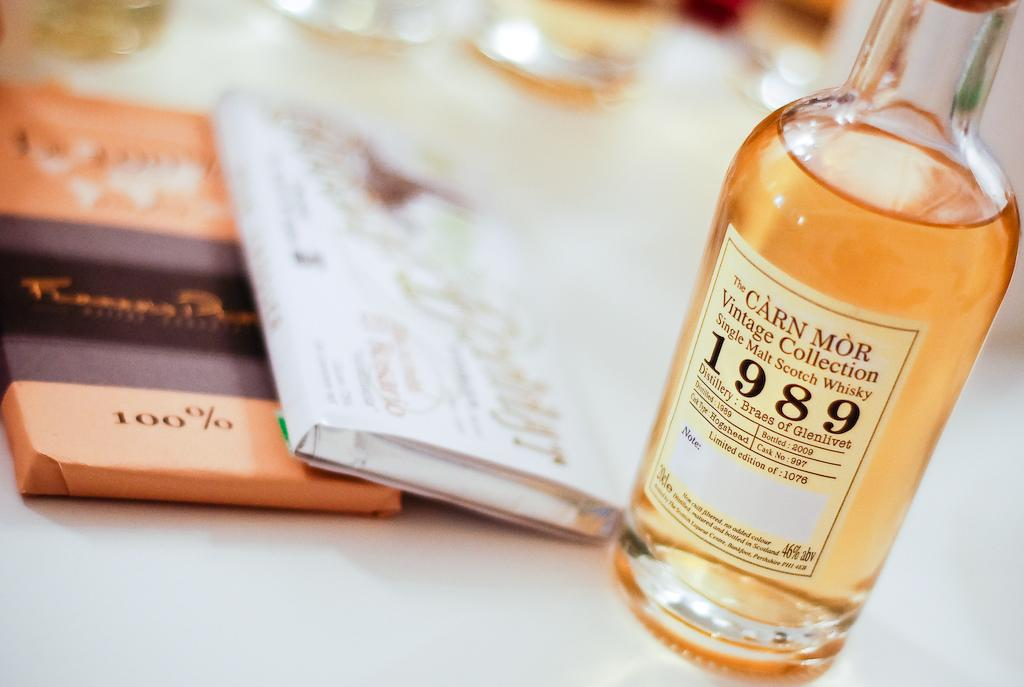<image>
Offer a succinct explanation of the picture presented. a bottle of 1989 carn mor vintage collection 